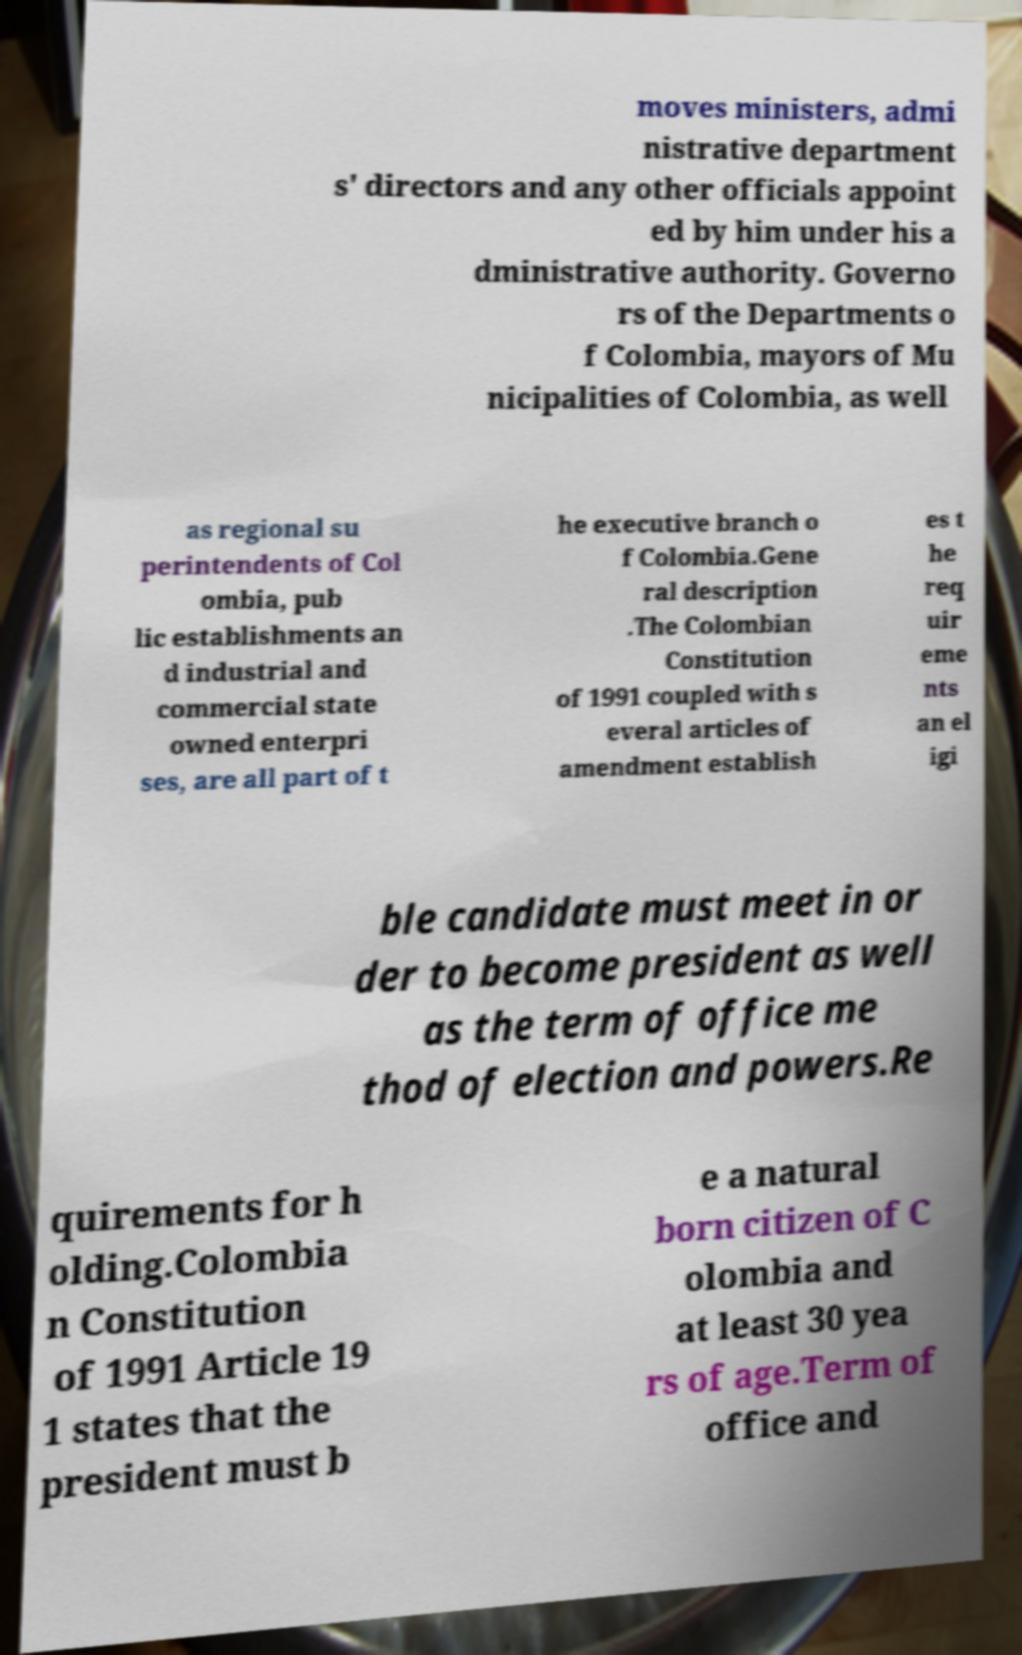Could you extract and type out the text from this image? moves ministers, admi nistrative department s' directors and any other officials appoint ed by him under his a dministrative authority. Governo rs of the Departments o f Colombia, mayors of Mu nicipalities of Colombia, as well as regional su perintendents of Col ombia, pub lic establishments an d industrial and commercial state owned enterpri ses, are all part of t he executive branch o f Colombia.Gene ral description .The Colombian Constitution of 1991 coupled with s everal articles of amendment establish es t he req uir eme nts an el igi ble candidate must meet in or der to become president as well as the term of office me thod of election and powers.Re quirements for h olding.Colombia n Constitution of 1991 Article 19 1 states that the president must b e a natural born citizen of C olombia and at least 30 yea rs of age.Term of office and 